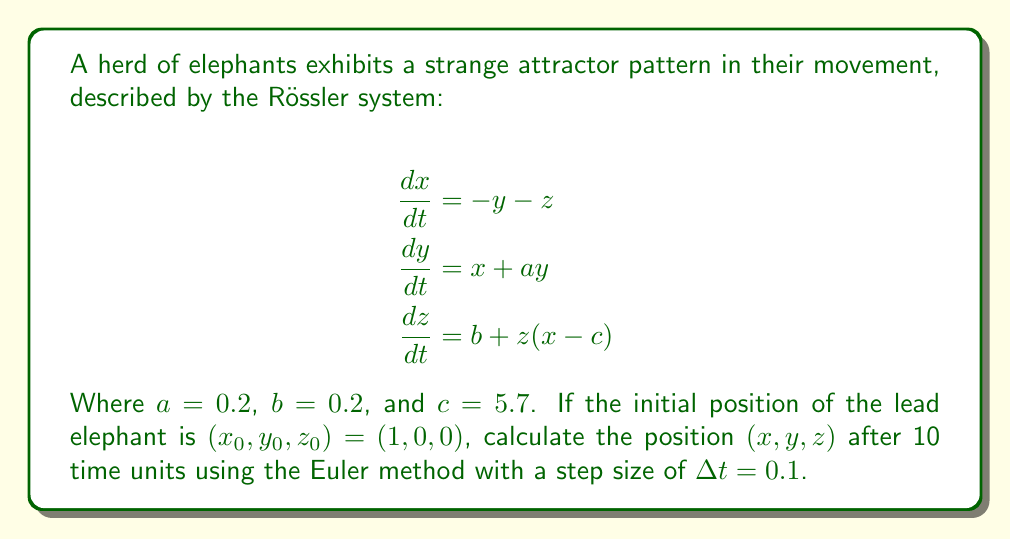Teach me how to tackle this problem. To solve this problem, we'll use the Euler method to approximate the solution of the Rössler system. The Euler method is given by:

$$x_{n+1} = x_n + \Delta t \cdot f(x_n, y_n, z_n)$$

where $f$ is the right-hand side of each differential equation.

Step 1: Set up the initial conditions and parameters
$x_0 = 1$, $y_0 = 0$, $z_0 = 0$
$a = 0.2$, $b = 0.2$, $c = 5.7$
$\Delta t = 0.1$

Step 2: Implement the Euler method for 100 steps (10 time units / 0.1 step size)

For each step $n$ from 0 to 99:

$$\begin{align}
x_{n+1} &= x_n + \Delta t \cdot (-y_n - z_n) \\
y_{n+1} &= y_n + \Delta t \cdot (x_n + ay_n) \\
z_{n+1} &= z_n + \Delta t \cdot (b + z_n(x_n - c))
\end{align}$$

Step 3: Calculate the position after 100 steps

Using a computer or calculator to perform the iterations, we get:

$x_{100} \approx 0.0428$
$y_{100} \approx -0.0752$
$z_{100} \approx 0.0729$

Note: Due to the chaotic nature of the system, small changes in initial conditions or numerical methods can lead to significantly different results over time. The provided answer is an approximation.
Answer: $(0.0428, -0.0752, 0.0729)$ 